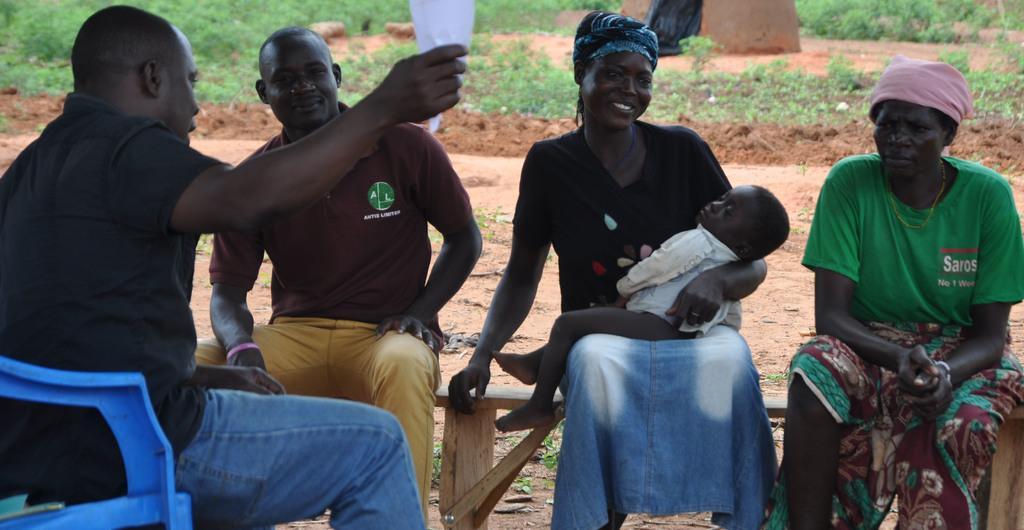In one or two sentences, can you explain what this image depicts? In this image we can see some people sitting on the surface. One person is holding a paper in his hand. One woman is holding a baby with her hand. In the background, we can see some plants. 